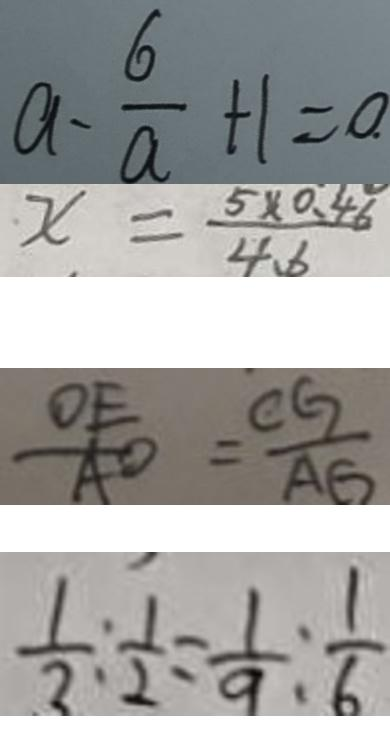Convert formula to latex. <formula><loc_0><loc_0><loc_500><loc_500>a - \frac { 6 } { a } + 1 = 0 . 
 x = \frac { 5 \times 0 . 4 6 } { 4 . 6 } 
 \frac { O E } { A O } = \frac { C G } { A G } 
 \frac { 1 } { 3 } : \frac { 1 } { 2 } = \frac { 1 } { 9 } : \frac { 1 } { 6 }</formula> 